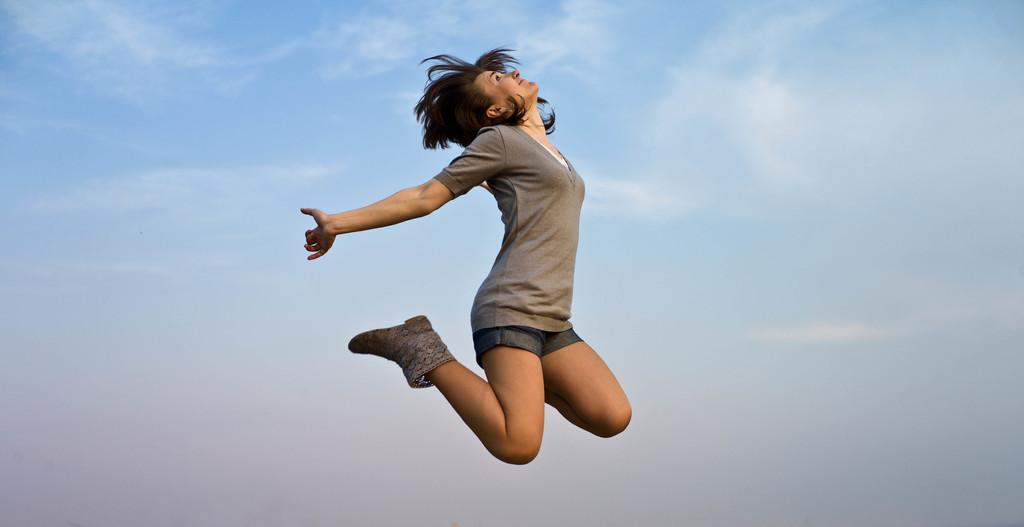Who is the main subject in the image? There is a woman in the image. What is the woman doing in the image? The woman is in the air. What type of clothing is the woman wearing? The woman is wearing a t-shirt and shorts. What type of footwear is the woman wearing? The woman is wearing footwear. What can be seen in the background of the image? The sky is visible in the background of the image. What news can be heard coming from the radio in the image? There is no radio present in the image, so it's not possible to determine what news might be heard. 